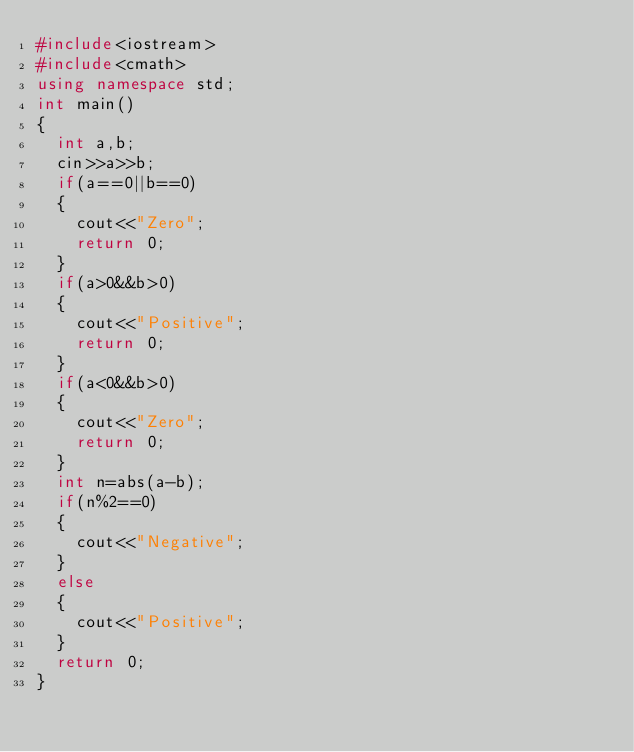<code> <loc_0><loc_0><loc_500><loc_500><_C++_>#include<iostream>
#include<cmath>
using namespace std;
int main()
{
	int a,b;
	cin>>a>>b;
	if(a==0||b==0)
	{
		cout<<"Zero";
		return 0;
	}
	if(a>0&&b>0)
	{
		cout<<"Positive";
		return 0;
	}
	if(a<0&&b>0)
	{
		cout<<"Zero";
		return 0;
	}
	int n=abs(a-b);
	if(n%2==0)
	{
		cout<<"Negative";
	}
	else
	{
		cout<<"Positive";
	}
	return 0;
}</code> 